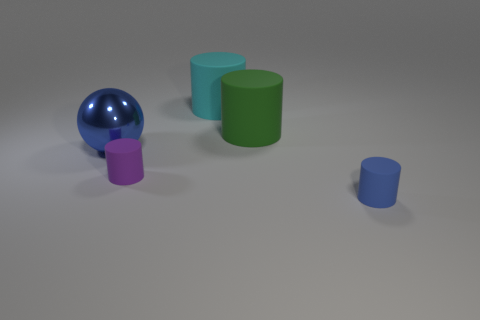Is there anything else that is the same material as the ball?
Give a very brief answer. No. There is a matte object that is in front of the small cylinder that is to the left of the blue thing that is on the right side of the small purple object; how big is it?
Give a very brief answer. Small. The large thing that is both right of the tiny purple object and in front of the large cyan cylinder is what color?
Offer a terse response. Green. Does the cyan cylinder have the same size as the matte cylinder that is on the right side of the green matte thing?
Your answer should be compact. No. Are there any other things that are the same shape as the big blue shiny object?
Offer a terse response. No. The other tiny object that is the same shape as the blue rubber thing is what color?
Give a very brief answer. Purple. Do the shiny thing and the purple thing have the same size?
Your response must be concise. No. What number of other objects are there of the same size as the blue ball?
Provide a succinct answer. 2. How many things are either small matte cylinders that are behind the small blue object or blue things left of the tiny blue thing?
Offer a very short reply. 2. The green thing that is the same size as the cyan cylinder is what shape?
Your response must be concise. Cylinder. 